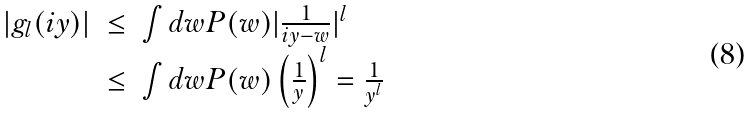Convert formula to latex. <formula><loc_0><loc_0><loc_500><loc_500>\begin{array} { l l l } | g _ { l } ( i y ) | & \leq & \int d w P ( w ) | \frac { 1 } { i y - w } | ^ { l } \\ & \leq & \int d w P ( w ) \left ( \frac { 1 } { y } \right ) ^ { l } = \frac { 1 } { y ^ { l } } \end{array}</formula> 